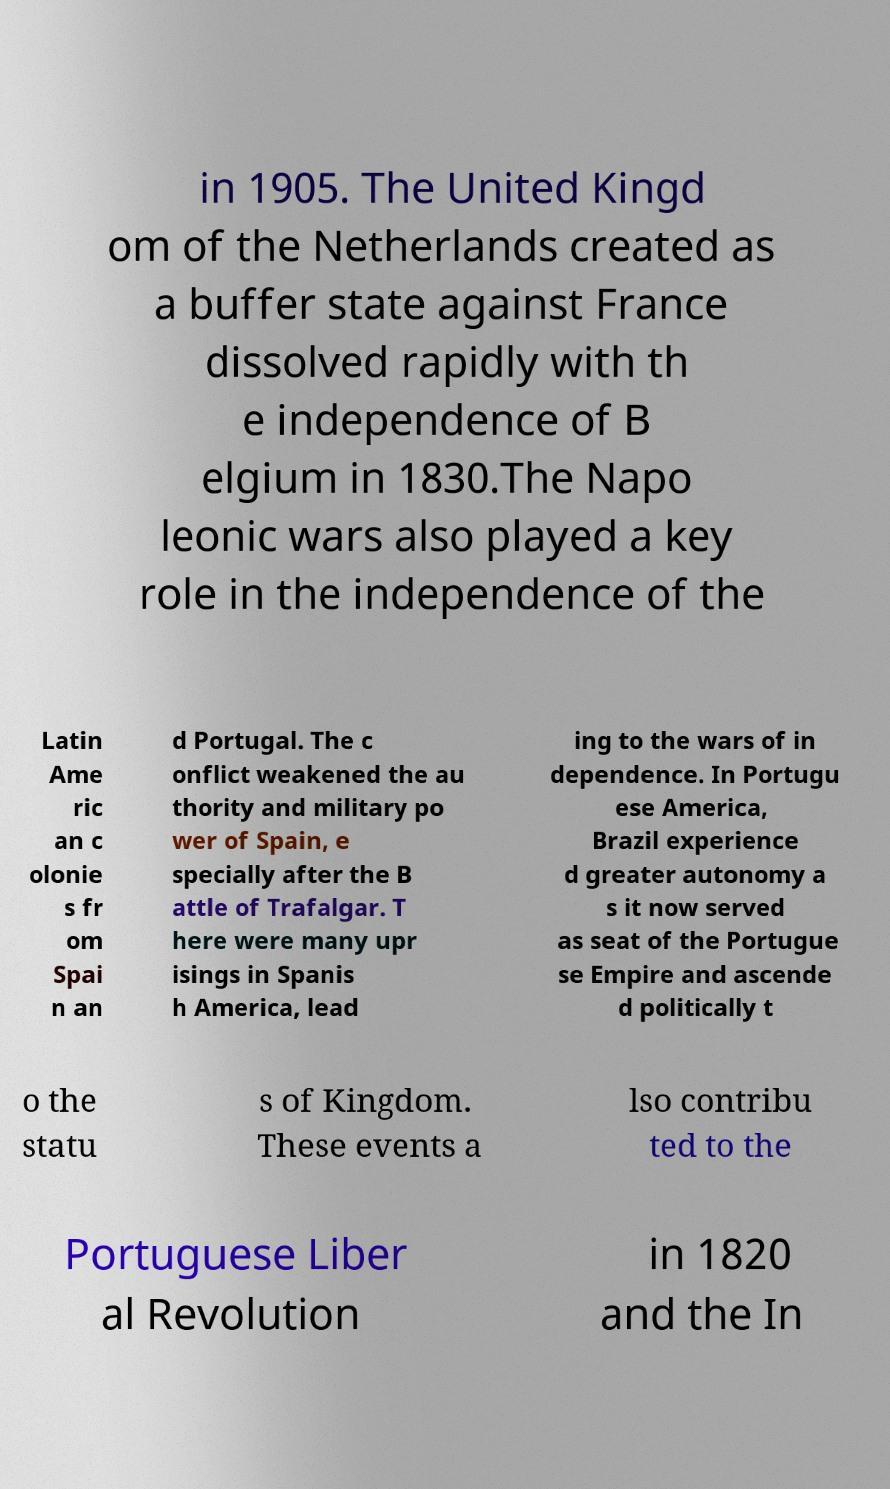Please read and relay the text visible in this image. What does it say? in 1905. The United Kingd om of the Netherlands created as a buffer state against France dissolved rapidly with th e independence of B elgium in 1830.The Napo leonic wars also played a key role in the independence of the Latin Ame ric an c olonie s fr om Spai n an d Portugal. The c onflict weakened the au thority and military po wer of Spain, e specially after the B attle of Trafalgar. T here were many upr isings in Spanis h America, lead ing to the wars of in dependence. In Portugu ese America, Brazil experience d greater autonomy a s it now served as seat of the Portugue se Empire and ascende d politically t o the statu s of Kingdom. These events a lso contribu ted to the Portuguese Liber al Revolution in 1820 and the In 